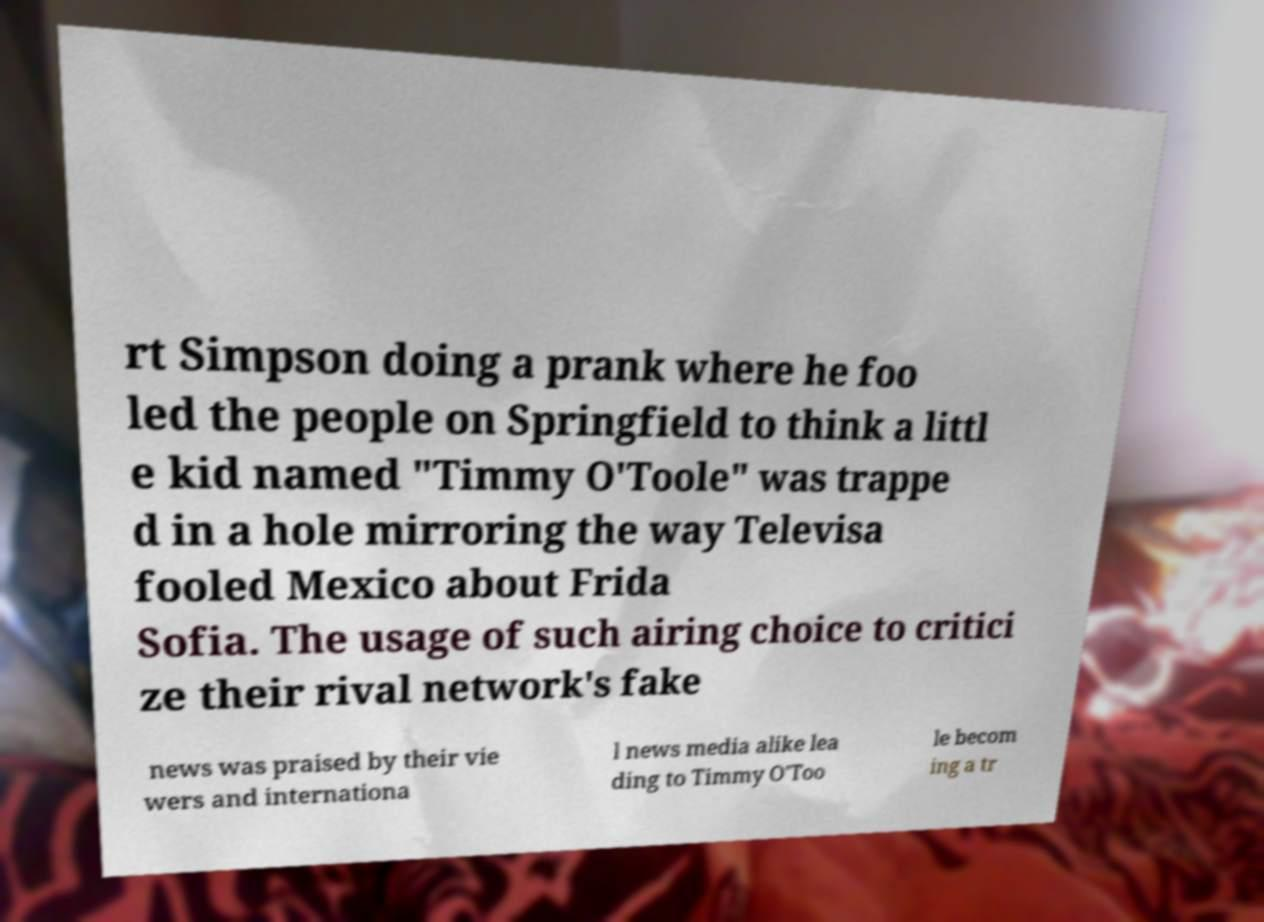There's text embedded in this image that I need extracted. Can you transcribe it verbatim? rt Simpson doing a prank where he foo led the people on Springfield to think a littl e kid named "Timmy O'Toole" was trappe d in a hole mirroring the way Televisa fooled Mexico about Frida Sofia. The usage of such airing choice to critici ze their rival network's fake news was praised by their vie wers and internationa l news media alike lea ding to Timmy O'Too le becom ing a tr 